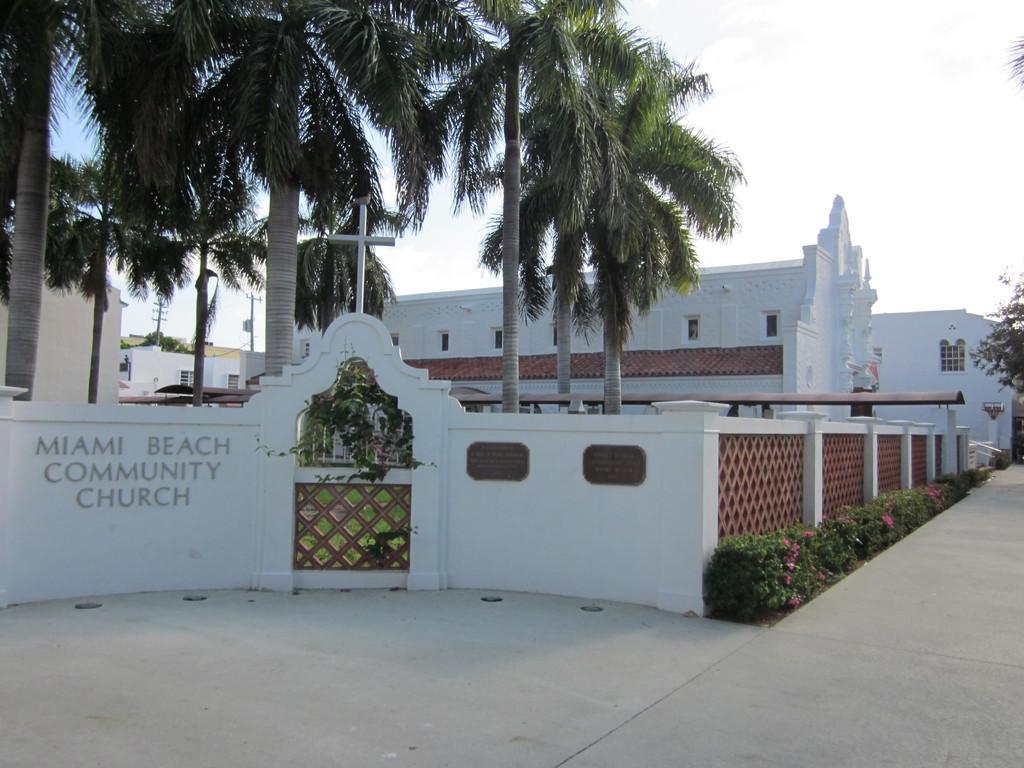Please provide a concise description of this image. In this picture there is a white color church. In the front there is a white boundary with some plants. On the left side there is a church naming board. Behind there are some coconut trees. 